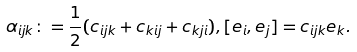Convert formula to latex. <formula><loc_0><loc_0><loc_500><loc_500>\alpha _ { i j k } \colon = \frac { 1 } { 2 } ( c _ { i j k } + c _ { k i j } + c _ { k j i } ) , [ e _ { i } , e _ { j } ] = c _ { i j k } e _ { k } .</formula> 